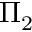<formula> <loc_0><loc_0><loc_500><loc_500>\Pi _ { 2 }</formula> 